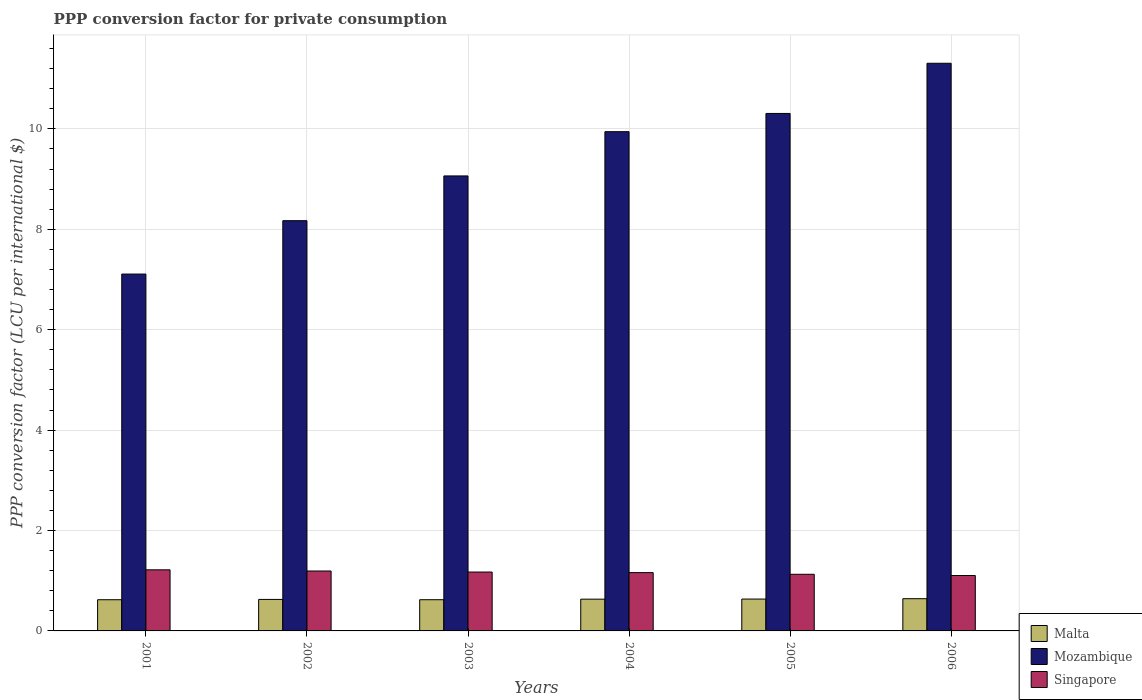How many groups of bars are there?
Provide a short and direct response. 6. How many bars are there on the 6th tick from the left?
Make the answer very short. 3. What is the PPP conversion factor for private consumption in Singapore in 2001?
Your answer should be compact. 1.22. Across all years, what is the maximum PPP conversion factor for private consumption in Mozambique?
Ensure brevity in your answer.  11.31. Across all years, what is the minimum PPP conversion factor for private consumption in Singapore?
Keep it short and to the point. 1.1. In which year was the PPP conversion factor for private consumption in Singapore maximum?
Offer a terse response. 2001. In which year was the PPP conversion factor for private consumption in Mozambique minimum?
Keep it short and to the point. 2001. What is the total PPP conversion factor for private consumption in Malta in the graph?
Offer a very short reply. 3.78. What is the difference between the PPP conversion factor for private consumption in Singapore in 2002 and that in 2004?
Make the answer very short. 0.03. What is the difference between the PPP conversion factor for private consumption in Malta in 2003 and the PPP conversion factor for private consumption in Mozambique in 2005?
Your answer should be compact. -9.68. What is the average PPP conversion factor for private consumption in Malta per year?
Your answer should be compact. 0.63. In the year 2005, what is the difference between the PPP conversion factor for private consumption in Malta and PPP conversion factor for private consumption in Mozambique?
Your answer should be compact. -9.67. What is the ratio of the PPP conversion factor for private consumption in Malta in 2002 to that in 2006?
Give a very brief answer. 0.98. What is the difference between the highest and the second highest PPP conversion factor for private consumption in Singapore?
Keep it short and to the point. 0.02. What is the difference between the highest and the lowest PPP conversion factor for private consumption in Singapore?
Provide a succinct answer. 0.11. What does the 2nd bar from the left in 2001 represents?
Your response must be concise. Mozambique. What does the 2nd bar from the right in 2004 represents?
Provide a succinct answer. Mozambique. Is it the case that in every year, the sum of the PPP conversion factor for private consumption in Singapore and PPP conversion factor for private consumption in Mozambique is greater than the PPP conversion factor for private consumption in Malta?
Give a very brief answer. Yes. How many bars are there?
Provide a short and direct response. 18. Are all the bars in the graph horizontal?
Your response must be concise. No. What is the difference between two consecutive major ticks on the Y-axis?
Your response must be concise. 2. Are the values on the major ticks of Y-axis written in scientific E-notation?
Your answer should be compact. No. Does the graph contain any zero values?
Provide a succinct answer. No. Where does the legend appear in the graph?
Provide a succinct answer. Bottom right. How many legend labels are there?
Make the answer very short. 3. How are the legend labels stacked?
Your answer should be compact. Vertical. What is the title of the graph?
Offer a terse response. PPP conversion factor for private consumption. Does "China" appear as one of the legend labels in the graph?
Give a very brief answer. No. What is the label or title of the Y-axis?
Offer a terse response. PPP conversion factor (LCU per international $). What is the PPP conversion factor (LCU per international $) in Malta in 2001?
Give a very brief answer. 0.62. What is the PPP conversion factor (LCU per international $) of Mozambique in 2001?
Give a very brief answer. 7.11. What is the PPP conversion factor (LCU per international $) in Singapore in 2001?
Make the answer very short. 1.22. What is the PPP conversion factor (LCU per international $) of Malta in 2002?
Make the answer very short. 0.63. What is the PPP conversion factor (LCU per international $) in Mozambique in 2002?
Offer a terse response. 8.17. What is the PPP conversion factor (LCU per international $) of Singapore in 2002?
Offer a terse response. 1.19. What is the PPP conversion factor (LCU per international $) in Malta in 2003?
Keep it short and to the point. 0.62. What is the PPP conversion factor (LCU per international $) of Mozambique in 2003?
Make the answer very short. 9.06. What is the PPP conversion factor (LCU per international $) in Singapore in 2003?
Offer a very short reply. 1.17. What is the PPP conversion factor (LCU per international $) of Malta in 2004?
Your response must be concise. 0.63. What is the PPP conversion factor (LCU per international $) in Mozambique in 2004?
Provide a succinct answer. 9.94. What is the PPP conversion factor (LCU per international $) of Singapore in 2004?
Give a very brief answer. 1.16. What is the PPP conversion factor (LCU per international $) in Malta in 2005?
Ensure brevity in your answer.  0.63. What is the PPP conversion factor (LCU per international $) in Mozambique in 2005?
Make the answer very short. 10.31. What is the PPP conversion factor (LCU per international $) in Singapore in 2005?
Make the answer very short. 1.13. What is the PPP conversion factor (LCU per international $) in Malta in 2006?
Keep it short and to the point. 0.64. What is the PPP conversion factor (LCU per international $) in Mozambique in 2006?
Make the answer very short. 11.31. What is the PPP conversion factor (LCU per international $) in Singapore in 2006?
Provide a succinct answer. 1.1. Across all years, what is the maximum PPP conversion factor (LCU per international $) of Malta?
Provide a short and direct response. 0.64. Across all years, what is the maximum PPP conversion factor (LCU per international $) in Mozambique?
Make the answer very short. 11.31. Across all years, what is the maximum PPP conversion factor (LCU per international $) of Singapore?
Offer a terse response. 1.22. Across all years, what is the minimum PPP conversion factor (LCU per international $) of Malta?
Your response must be concise. 0.62. Across all years, what is the minimum PPP conversion factor (LCU per international $) of Mozambique?
Provide a succinct answer. 7.11. Across all years, what is the minimum PPP conversion factor (LCU per international $) of Singapore?
Keep it short and to the point. 1.1. What is the total PPP conversion factor (LCU per international $) in Malta in the graph?
Make the answer very short. 3.78. What is the total PPP conversion factor (LCU per international $) of Mozambique in the graph?
Your response must be concise. 55.9. What is the total PPP conversion factor (LCU per international $) of Singapore in the graph?
Your response must be concise. 6.98. What is the difference between the PPP conversion factor (LCU per international $) of Malta in 2001 and that in 2002?
Your response must be concise. -0.01. What is the difference between the PPP conversion factor (LCU per international $) in Mozambique in 2001 and that in 2002?
Make the answer very short. -1.06. What is the difference between the PPP conversion factor (LCU per international $) in Singapore in 2001 and that in 2002?
Ensure brevity in your answer.  0.02. What is the difference between the PPP conversion factor (LCU per international $) of Malta in 2001 and that in 2003?
Your answer should be very brief. -0. What is the difference between the PPP conversion factor (LCU per international $) in Mozambique in 2001 and that in 2003?
Provide a succinct answer. -1.95. What is the difference between the PPP conversion factor (LCU per international $) of Singapore in 2001 and that in 2003?
Your answer should be very brief. 0.04. What is the difference between the PPP conversion factor (LCU per international $) in Malta in 2001 and that in 2004?
Your response must be concise. -0.01. What is the difference between the PPP conversion factor (LCU per international $) of Mozambique in 2001 and that in 2004?
Give a very brief answer. -2.84. What is the difference between the PPP conversion factor (LCU per international $) in Singapore in 2001 and that in 2004?
Provide a short and direct response. 0.06. What is the difference between the PPP conversion factor (LCU per international $) of Malta in 2001 and that in 2005?
Make the answer very short. -0.01. What is the difference between the PPP conversion factor (LCU per international $) in Mozambique in 2001 and that in 2005?
Keep it short and to the point. -3.2. What is the difference between the PPP conversion factor (LCU per international $) in Singapore in 2001 and that in 2005?
Your response must be concise. 0.09. What is the difference between the PPP conversion factor (LCU per international $) of Malta in 2001 and that in 2006?
Offer a terse response. -0.02. What is the difference between the PPP conversion factor (LCU per international $) of Mozambique in 2001 and that in 2006?
Provide a short and direct response. -4.2. What is the difference between the PPP conversion factor (LCU per international $) of Singapore in 2001 and that in 2006?
Keep it short and to the point. 0.11. What is the difference between the PPP conversion factor (LCU per international $) of Malta in 2002 and that in 2003?
Your answer should be very brief. 0.01. What is the difference between the PPP conversion factor (LCU per international $) in Mozambique in 2002 and that in 2003?
Your answer should be compact. -0.89. What is the difference between the PPP conversion factor (LCU per international $) of Singapore in 2002 and that in 2003?
Give a very brief answer. 0.02. What is the difference between the PPP conversion factor (LCU per international $) of Malta in 2002 and that in 2004?
Give a very brief answer. -0.01. What is the difference between the PPP conversion factor (LCU per international $) in Mozambique in 2002 and that in 2004?
Give a very brief answer. -1.77. What is the difference between the PPP conversion factor (LCU per international $) of Singapore in 2002 and that in 2004?
Your response must be concise. 0.03. What is the difference between the PPP conversion factor (LCU per international $) in Malta in 2002 and that in 2005?
Your response must be concise. -0.01. What is the difference between the PPP conversion factor (LCU per international $) of Mozambique in 2002 and that in 2005?
Offer a terse response. -2.14. What is the difference between the PPP conversion factor (LCU per international $) in Singapore in 2002 and that in 2005?
Your answer should be compact. 0.07. What is the difference between the PPP conversion factor (LCU per international $) of Malta in 2002 and that in 2006?
Your answer should be compact. -0.01. What is the difference between the PPP conversion factor (LCU per international $) of Mozambique in 2002 and that in 2006?
Keep it short and to the point. -3.14. What is the difference between the PPP conversion factor (LCU per international $) in Singapore in 2002 and that in 2006?
Offer a terse response. 0.09. What is the difference between the PPP conversion factor (LCU per international $) in Malta in 2003 and that in 2004?
Offer a terse response. -0.01. What is the difference between the PPP conversion factor (LCU per international $) of Mozambique in 2003 and that in 2004?
Your answer should be compact. -0.88. What is the difference between the PPP conversion factor (LCU per international $) of Singapore in 2003 and that in 2004?
Your answer should be very brief. 0.01. What is the difference between the PPP conversion factor (LCU per international $) in Malta in 2003 and that in 2005?
Provide a short and direct response. -0.01. What is the difference between the PPP conversion factor (LCU per international $) of Mozambique in 2003 and that in 2005?
Your answer should be compact. -1.24. What is the difference between the PPP conversion factor (LCU per international $) in Singapore in 2003 and that in 2005?
Your answer should be very brief. 0.04. What is the difference between the PPP conversion factor (LCU per international $) of Malta in 2003 and that in 2006?
Give a very brief answer. -0.02. What is the difference between the PPP conversion factor (LCU per international $) in Mozambique in 2003 and that in 2006?
Offer a very short reply. -2.24. What is the difference between the PPP conversion factor (LCU per international $) in Singapore in 2003 and that in 2006?
Offer a very short reply. 0.07. What is the difference between the PPP conversion factor (LCU per international $) in Malta in 2004 and that in 2005?
Provide a short and direct response. -0. What is the difference between the PPP conversion factor (LCU per international $) in Mozambique in 2004 and that in 2005?
Provide a short and direct response. -0.36. What is the difference between the PPP conversion factor (LCU per international $) in Malta in 2004 and that in 2006?
Ensure brevity in your answer.  -0.01. What is the difference between the PPP conversion factor (LCU per international $) of Mozambique in 2004 and that in 2006?
Ensure brevity in your answer.  -1.36. What is the difference between the PPP conversion factor (LCU per international $) in Singapore in 2004 and that in 2006?
Offer a terse response. 0.06. What is the difference between the PPP conversion factor (LCU per international $) of Malta in 2005 and that in 2006?
Your response must be concise. -0.01. What is the difference between the PPP conversion factor (LCU per international $) in Mozambique in 2005 and that in 2006?
Offer a very short reply. -1. What is the difference between the PPP conversion factor (LCU per international $) of Singapore in 2005 and that in 2006?
Offer a terse response. 0.02. What is the difference between the PPP conversion factor (LCU per international $) of Malta in 2001 and the PPP conversion factor (LCU per international $) of Mozambique in 2002?
Ensure brevity in your answer.  -7.55. What is the difference between the PPP conversion factor (LCU per international $) of Malta in 2001 and the PPP conversion factor (LCU per international $) of Singapore in 2002?
Your answer should be very brief. -0.57. What is the difference between the PPP conversion factor (LCU per international $) in Mozambique in 2001 and the PPP conversion factor (LCU per international $) in Singapore in 2002?
Keep it short and to the point. 5.91. What is the difference between the PPP conversion factor (LCU per international $) in Malta in 2001 and the PPP conversion factor (LCU per international $) in Mozambique in 2003?
Your answer should be compact. -8.44. What is the difference between the PPP conversion factor (LCU per international $) in Malta in 2001 and the PPP conversion factor (LCU per international $) in Singapore in 2003?
Your response must be concise. -0.55. What is the difference between the PPP conversion factor (LCU per international $) in Mozambique in 2001 and the PPP conversion factor (LCU per international $) in Singapore in 2003?
Your answer should be very brief. 5.93. What is the difference between the PPP conversion factor (LCU per international $) in Malta in 2001 and the PPP conversion factor (LCU per international $) in Mozambique in 2004?
Make the answer very short. -9.32. What is the difference between the PPP conversion factor (LCU per international $) of Malta in 2001 and the PPP conversion factor (LCU per international $) of Singapore in 2004?
Provide a short and direct response. -0.54. What is the difference between the PPP conversion factor (LCU per international $) in Mozambique in 2001 and the PPP conversion factor (LCU per international $) in Singapore in 2004?
Your answer should be compact. 5.95. What is the difference between the PPP conversion factor (LCU per international $) of Malta in 2001 and the PPP conversion factor (LCU per international $) of Mozambique in 2005?
Ensure brevity in your answer.  -9.69. What is the difference between the PPP conversion factor (LCU per international $) in Malta in 2001 and the PPP conversion factor (LCU per international $) in Singapore in 2005?
Offer a very short reply. -0.51. What is the difference between the PPP conversion factor (LCU per international $) in Mozambique in 2001 and the PPP conversion factor (LCU per international $) in Singapore in 2005?
Provide a succinct answer. 5.98. What is the difference between the PPP conversion factor (LCU per international $) of Malta in 2001 and the PPP conversion factor (LCU per international $) of Mozambique in 2006?
Your answer should be compact. -10.68. What is the difference between the PPP conversion factor (LCU per international $) in Malta in 2001 and the PPP conversion factor (LCU per international $) in Singapore in 2006?
Keep it short and to the point. -0.48. What is the difference between the PPP conversion factor (LCU per international $) of Mozambique in 2001 and the PPP conversion factor (LCU per international $) of Singapore in 2006?
Keep it short and to the point. 6. What is the difference between the PPP conversion factor (LCU per international $) of Malta in 2002 and the PPP conversion factor (LCU per international $) of Mozambique in 2003?
Ensure brevity in your answer.  -8.43. What is the difference between the PPP conversion factor (LCU per international $) of Malta in 2002 and the PPP conversion factor (LCU per international $) of Singapore in 2003?
Your answer should be compact. -0.55. What is the difference between the PPP conversion factor (LCU per international $) of Mozambique in 2002 and the PPP conversion factor (LCU per international $) of Singapore in 2003?
Give a very brief answer. 7. What is the difference between the PPP conversion factor (LCU per international $) of Malta in 2002 and the PPP conversion factor (LCU per international $) of Mozambique in 2004?
Make the answer very short. -9.32. What is the difference between the PPP conversion factor (LCU per international $) of Malta in 2002 and the PPP conversion factor (LCU per international $) of Singapore in 2004?
Ensure brevity in your answer.  -0.53. What is the difference between the PPP conversion factor (LCU per international $) of Mozambique in 2002 and the PPP conversion factor (LCU per international $) of Singapore in 2004?
Provide a succinct answer. 7.01. What is the difference between the PPP conversion factor (LCU per international $) of Malta in 2002 and the PPP conversion factor (LCU per international $) of Mozambique in 2005?
Give a very brief answer. -9.68. What is the difference between the PPP conversion factor (LCU per international $) in Malta in 2002 and the PPP conversion factor (LCU per international $) in Singapore in 2005?
Give a very brief answer. -0.5. What is the difference between the PPP conversion factor (LCU per international $) of Mozambique in 2002 and the PPP conversion factor (LCU per international $) of Singapore in 2005?
Provide a succinct answer. 7.04. What is the difference between the PPP conversion factor (LCU per international $) in Malta in 2002 and the PPP conversion factor (LCU per international $) in Mozambique in 2006?
Ensure brevity in your answer.  -10.68. What is the difference between the PPP conversion factor (LCU per international $) in Malta in 2002 and the PPP conversion factor (LCU per international $) in Singapore in 2006?
Make the answer very short. -0.48. What is the difference between the PPP conversion factor (LCU per international $) of Mozambique in 2002 and the PPP conversion factor (LCU per international $) of Singapore in 2006?
Your answer should be compact. 7.07. What is the difference between the PPP conversion factor (LCU per international $) in Malta in 2003 and the PPP conversion factor (LCU per international $) in Mozambique in 2004?
Ensure brevity in your answer.  -9.32. What is the difference between the PPP conversion factor (LCU per international $) of Malta in 2003 and the PPP conversion factor (LCU per international $) of Singapore in 2004?
Your response must be concise. -0.54. What is the difference between the PPP conversion factor (LCU per international $) in Mozambique in 2003 and the PPP conversion factor (LCU per international $) in Singapore in 2004?
Your answer should be compact. 7.9. What is the difference between the PPP conversion factor (LCU per international $) of Malta in 2003 and the PPP conversion factor (LCU per international $) of Mozambique in 2005?
Your response must be concise. -9.68. What is the difference between the PPP conversion factor (LCU per international $) of Malta in 2003 and the PPP conversion factor (LCU per international $) of Singapore in 2005?
Provide a succinct answer. -0.51. What is the difference between the PPP conversion factor (LCU per international $) in Mozambique in 2003 and the PPP conversion factor (LCU per international $) in Singapore in 2005?
Make the answer very short. 7.93. What is the difference between the PPP conversion factor (LCU per international $) in Malta in 2003 and the PPP conversion factor (LCU per international $) in Mozambique in 2006?
Offer a terse response. -10.68. What is the difference between the PPP conversion factor (LCU per international $) in Malta in 2003 and the PPP conversion factor (LCU per international $) in Singapore in 2006?
Provide a succinct answer. -0.48. What is the difference between the PPP conversion factor (LCU per international $) of Mozambique in 2003 and the PPP conversion factor (LCU per international $) of Singapore in 2006?
Make the answer very short. 7.96. What is the difference between the PPP conversion factor (LCU per international $) of Malta in 2004 and the PPP conversion factor (LCU per international $) of Mozambique in 2005?
Your response must be concise. -9.67. What is the difference between the PPP conversion factor (LCU per international $) in Malta in 2004 and the PPP conversion factor (LCU per international $) in Singapore in 2005?
Ensure brevity in your answer.  -0.5. What is the difference between the PPP conversion factor (LCU per international $) in Mozambique in 2004 and the PPP conversion factor (LCU per international $) in Singapore in 2005?
Ensure brevity in your answer.  8.82. What is the difference between the PPP conversion factor (LCU per international $) in Malta in 2004 and the PPP conversion factor (LCU per international $) in Mozambique in 2006?
Make the answer very short. -10.67. What is the difference between the PPP conversion factor (LCU per international $) in Malta in 2004 and the PPP conversion factor (LCU per international $) in Singapore in 2006?
Your answer should be compact. -0.47. What is the difference between the PPP conversion factor (LCU per international $) in Mozambique in 2004 and the PPP conversion factor (LCU per international $) in Singapore in 2006?
Your answer should be very brief. 8.84. What is the difference between the PPP conversion factor (LCU per international $) of Malta in 2005 and the PPP conversion factor (LCU per international $) of Mozambique in 2006?
Your response must be concise. -10.67. What is the difference between the PPP conversion factor (LCU per international $) of Malta in 2005 and the PPP conversion factor (LCU per international $) of Singapore in 2006?
Provide a short and direct response. -0.47. What is the difference between the PPP conversion factor (LCU per international $) of Mozambique in 2005 and the PPP conversion factor (LCU per international $) of Singapore in 2006?
Offer a terse response. 9.2. What is the average PPP conversion factor (LCU per international $) of Malta per year?
Offer a very short reply. 0.63. What is the average PPP conversion factor (LCU per international $) in Mozambique per year?
Provide a short and direct response. 9.32. What is the average PPP conversion factor (LCU per international $) of Singapore per year?
Keep it short and to the point. 1.16. In the year 2001, what is the difference between the PPP conversion factor (LCU per international $) in Malta and PPP conversion factor (LCU per international $) in Mozambique?
Provide a succinct answer. -6.49. In the year 2001, what is the difference between the PPP conversion factor (LCU per international $) in Malta and PPP conversion factor (LCU per international $) in Singapore?
Keep it short and to the point. -0.6. In the year 2001, what is the difference between the PPP conversion factor (LCU per international $) in Mozambique and PPP conversion factor (LCU per international $) in Singapore?
Your answer should be very brief. 5.89. In the year 2002, what is the difference between the PPP conversion factor (LCU per international $) in Malta and PPP conversion factor (LCU per international $) in Mozambique?
Provide a short and direct response. -7.54. In the year 2002, what is the difference between the PPP conversion factor (LCU per international $) of Malta and PPP conversion factor (LCU per international $) of Singapore?
Make the answer very short. -0.57. In the year 2002, what is the difference between the PPP conversion factor (LCU per international $) in Mozambique and PPP conversion factor (LCU per international $) in Singapore?
Ensure brevity in your answer.  6.98. In the year 2003, what is the difference between the PPP conversion factor (LCU per international $) in Malta and PPP conversion factor (LCU per international $) in Mozambique?
Your response must be concise. -8.44. In the year 2003, what is the difference between the PPP conversion factor (LCU per international $) in Malta and PPP conversion factor (LCU per international $) in Singapore?
Make the answer very short. -0.55. In the year 2003, what is the difference between the PPP conversion factor (LCU per international $) of Mozambique and PPP conversion factor (LCU per international $) of Singapore?
Offer a very short reply. 7.89. In the year 2004, what is the difference between the PPP conversion factor (LCU per international $) in Malta and PPP conversion factor (LCU per international $) in Mozambique?
Ensure brevity in your answer.  -9.31. In the year 2004, what is the difference between the PPP conversion factor (LCU per international $) of Malta and PPP conversion factor (LCU per international $) of Singapore?
Make the answer very short. -0.53. In the year 2004, what is the difference between the PPP conversion factor (LCU per international $) in Mozambique and PPP conversion factor (LCU per international $) in Singapore?
Your answer should be very brief. 8.78. In the year 2005, what is the difference between the PPP conversion factor (LCU per international $) of Malta and PPP conversion factor (LCU per international $) of Mozambique?
Your answer should be very brief. -9.67. In the year 2005, what is the difference between the PPP conversion factor (LCU per international $) in Malta and PPP conversion factor (LCU per international $) in Singapore?
Make the answer very short. -0.49. In the year 2005, what is the difference between the PPP conversion factor (LCU per international $) of Mozambique and PPP conversion factor (LCU per international $) of Singapore?
Provide a succinct answer. 9.18. In the year 2006, what is the difference between the PPP conversion factor (LCU per international $) in Malta and PPP conversion factor (LCU per international $) in Mozambique?
Offer a very short reply. -10.66. In the year 2006, what is the difference between the PPP conversion factor (LCU per international $) in Malta and PPP conversion factor (LCU per international $) in Singapore?
Your answer should be very brief. -0.46. In the year 2006, what is the difference between the PPP conversion factor (LCU per international $) in Mozambique and PPP conversion factor (LCU per international $) in Singapore?
Ensure brevity in your answer.  10.2. What is the ratio of the PPP conversion factor (LCU per international $) of Malta in 2001 to that in 2002?
Your answer should be compact. 0.99. What is the ratio of the PPP conversion factor (LCU per international $) of Mozambique in 2001 to that in 2002?
Provide a succinct answer. 0.87. What is the ratio of the PPP conversion factor (LCU per international $) in Singapore in 2001 to that in 2002?
Provide a short and direct response. 1.02. What is the ratio of the PPP conversion factor (LCU per international $) of Malta in 2001 to that in 2003?
Keep it short and to the point. 1. What is the ratio of the PPP conversion factor (LCU per international $) in Mozambique in 2001 to that in 2003?
Provide a short and direct response. 0.78. What is the ratio of the PPP conversion factor (LCU per international $) of Singapore in 2001 to that in 2003?
Offer a very short reply. 1.04. What is the ratio of the PPP conversion factor (LCU per international $) of Malta in 2001 to that in 2004?
Provide a short and direct response. 0.98. What is the ratio of the PPP conversion factor (LCU per international $) in Mozambique in 2001 to that in 2004?
Offer a very short reply. 0.71. What is the ratio of the PPP conversion factor (LCU per international $) in Singapore in 2001 to that in 2004?
Ensure brevity in your answer.  1.05. What is the ratio of the PPP conversion factor (LCU per international $) in Malta in 2001 to that in 2005?
Ensure brevity in your answer.  0.98. What is the ratio of the PPP conversion factor (LCU per international $) of Mozambique in 2001 to that in 2005?
Give a very brief answer. 0.69. What is the ratio of the PPP conversion factor (LCU per international $) in Singapore in 2001 to that in 2005?
Your answer should be very brief. 1.08. What is the ratio of the PPP conversion factor (LCU per international $) in Malta in 2001 to that in 2006?
Your answer should be compact. 0.97. What is the ratio of the PPP conversion factor (LCU per international $) of Mozambique in 2001 to that in 2006?
Your answer should be compact. 0.63. What is the ratio of the PPP conversion factor (LCU per international $) in Singapore in 2001 to that in 2006?
Give a very brief answer. 1.1. What is the ratio of the PPP conversion factor (LCU per international $) in Malta in 2002 to that in 2003?
Give a very brief answer. 1.01. What is the ratio of the PPP conversion factor (LCU per international $) in Mozambique in 2002 to that in 2003?
Give a very brief answer. 0.9. What is the ratio of the PPP conversion factor (LCU per international $) in Singapore in 2002 to that in 2003?
Your answer should be very brief. 1.02. What is the ratio of the PPP conversion factor (LCU per international $) in Mozambique in 2002 to that in 2004?
Your response must be concise. 0.82. What is the ratio of the PPP conversion factor (LCU per international $) in Singapore in 2002 to that in 2004?
Offer a very short reply. 1.03. What is the ratio of the PPP conversion factor (LCU per international $) of Malta in 2002 to that in 2005?
Your answer should be compact. 0.99. What is the ratio of the PPP conversion factor (LCU per international $) in Mozambique in 2002 to that in 2005?
Make the answer very short. 0.79. What is the ratio of the PPP conversion factor (LCU per international $) of Singapore in 2002 to that in 2005?
Keep it short and to the point. 1.06. What is the ratio of the PPP conversion factor (LCU per international $) in Malta in 2002 to that in 2006?
Your answer should be compact. 0.98. What is the ratio of the PPP conversion factor (LCU per international $) of Mozambique in 2002 to that in 2006?
Offer a terse response. 0.72. What is the ratio of the PPP conversion factor (LCU per international $) of Singapore in 2002 to that in 2006?
Your answer should be compact. 1.08. What is the ratio of the PPP conversion factor (LCU per international $) in Malta in 2003 to that in 2004?
Your response must be concise. 0.98. What is the ratio of the PPP conversion factor (LCU per international $) in Mozambique in 2003 to that in 2004?
Your answer should be compact. 0.91. What is the ratio of the PPP conversion factor (LCU per international $) of Malta in 2003 to that in 2005?
Offer a very short reply. 0.98. What is the ratio of the PPP conversion factor (LCU per international $) in Mozambique in 2003 to that in 2005?
Offer a terse response. 0.88. What is the ratio of the PPP conversion factor (LCU per international $) in Singapore in 2003 to that in 2005?
Offer a very short reply. 1.04. What is the ratio of the PPP conversion factor (LCU per international $) of Malta in 2003 to that in 2006?
Ensure brevity in your answer.  0.97. What is the ratio of the PPP conversion factor (LCU per international $) of Mozambique in 2003 to that in 2006?
Provide a short and direct response. 0.8. What is the ratio of the PPP conversion factor (LCU per international $) of Singapore in 2003 to that in 2006?
Provide a succinct answer. 1.06. What is the ratio of the PPP conversion factor (LCU per international $) in Mozambique in 2004 to that in 2005?
Offer a terse response. 0.96. What is the ratio of the PPP conversion factor (LCU per international $) of Singapore in 2004 to that in 2005?
Offer a very short reply. 1.03. What is the ratio of the PPP conversion factor (LCU per international $) in Malta in 2004 to that in 2006?
Provide a short and direct response. 0.99. What is the ratio of the PPP conversion factor (LCU per international $) of Mozambique in 2004 to that in 2006?
Ensure brevity in your answer.  0.88. What is the ratio of the PPP conversion factor (LCU per international $) in Singapore in 2004 to that in 2006?
Ensure brevity in your answer.  1.05. What is the ratio of the PPP conversion factor (LCU per international $) of Malta in 2005 to that in 2006?
Your answer should be compact. 0.99. What is the ratio of the PPP conversion factor (LCU per international $) of Mozambique in 2005 to that in 2006?
Your answer should be compact. 0.91. What is the ratio of the PPP conversion factor (LCU per international $) in Singapore in 2005 to that in 2006?
Your response must be concise. 1.02. What is the difference between the highest and the second highest PPP conversion factor (LCU per international $) in Malta?
Your response must be concise. 0.01. What is the difference between the highest and the second highest PPP conversion factor (LCU per international $) in Mozambique?
Offer a very short reply. 1. What is the difference between the highest and the second highest PPP conversion factor (LCU per international $) of Singapore?
Give a very brief answer. 0.02. What is the difference between the highest and the lowest PPP conversion factor (LCU per international $) in Malta?
Your response must be concise. 0.02. What is the difference between the highest and the lowest PPP conversion factor (LCU per international $) of Mozambique?
Your response must be concise. 4.2. What is the difference between the highest and the lowest PPP conversion factor (LCU per international $) in Singapore?
Your answer should be compact. 0.11. 